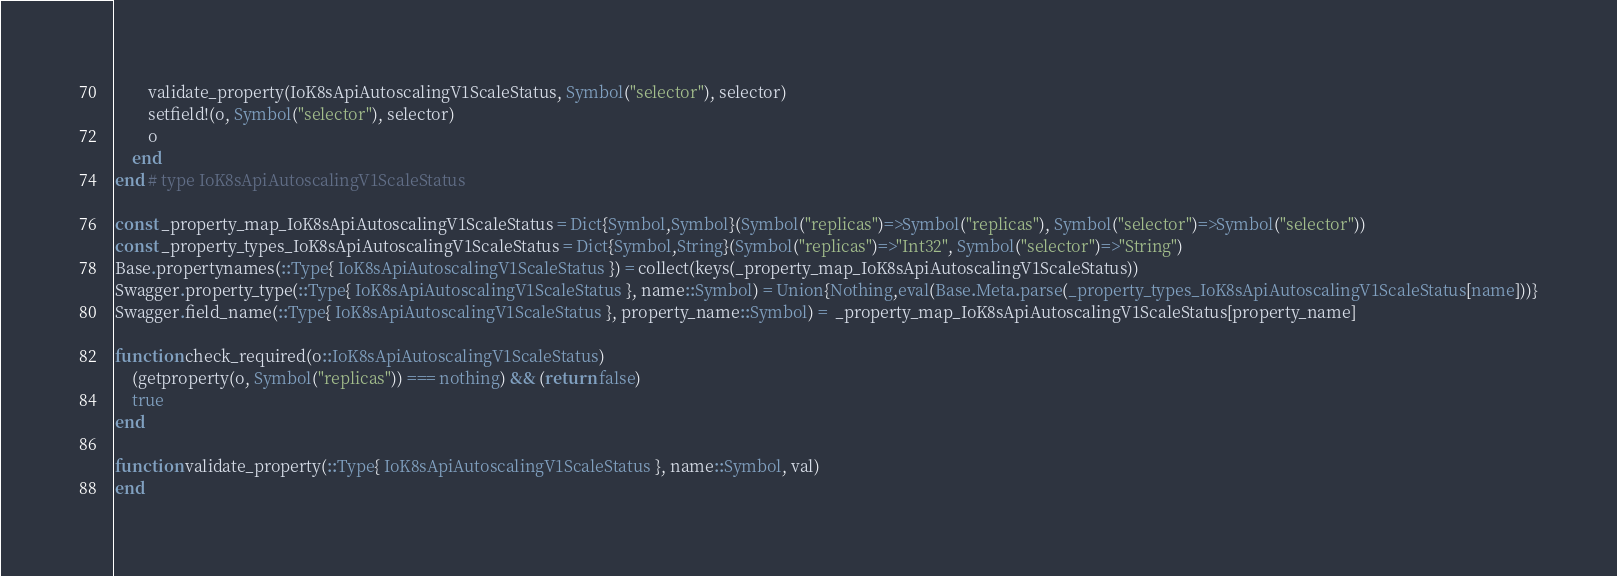Convert code to text. <code><loc_0><loc_0><loc_500><loc_500><_Julia_>        validate_property(IoK8sApiAutoscalingV1ScaleStatus, Symbol("selector"), selector)
        setfield!(o, Symbol("selector"), selector)
        o
    end
end # type IoK8sApiAutoscalingV1ScaleStatus

const _property_map_IoK8sApiAutoscalingV1ScaleStatus = Dict{Symbol,Symbol}(Symbol("replicas")=>Symbol("replicas"), Symbol("selector")=>Symbol("selector"))
const _property_types_IoK8sApiAutoscalingV1ScaleStatus = Dict{Symbol,String}(Symbol("replicas")=>"Int32", Symbol("selector")=>"String")
Base.propertynames(::Type{ IoK8sApiAutoscalingV1ScaleStatus }) = collect(keys(_property_map_IoK8sApiAutoscalingV1ScaleStatus))
Swagger.property_type(::Type{ IoK8sApiAutoscalingV1ScaleStatus }, name::Symbol) = Union{Nothing,eval(Base.Meta.parse(_property_types_IoK8sApiAutoscalingV1ScaleStatus[name]))}
Swagger.field_name(::Type{ IoK8sApiAutoscalingV1ScaleStatus }, property_name::Symbol) =  _property_map_IoK8sApiAutoscalingV1ScaleStatus[property_name]

function check_required(o::IoK8sApiAutoscalingV1ScaleStatus)
    (getproperty(o, Symbol("replicas")) === nothing) && (return false)
    true
end

function validate_property(::Type{ IoK8sApiAutoscalingV1ScaleStatus }, name::Symbol, val)
end
</code> 